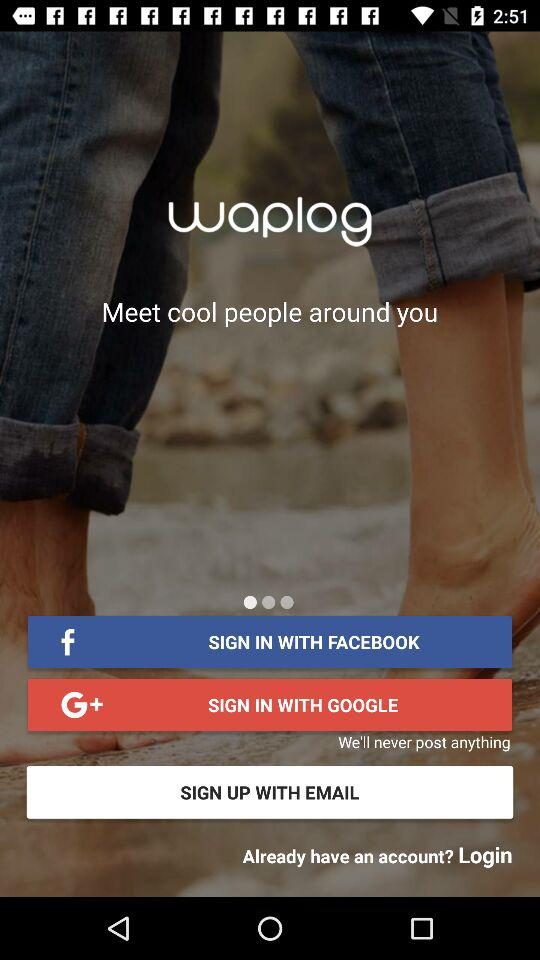How many signup options are available?
Answer the question using a single word or phrase. 3 